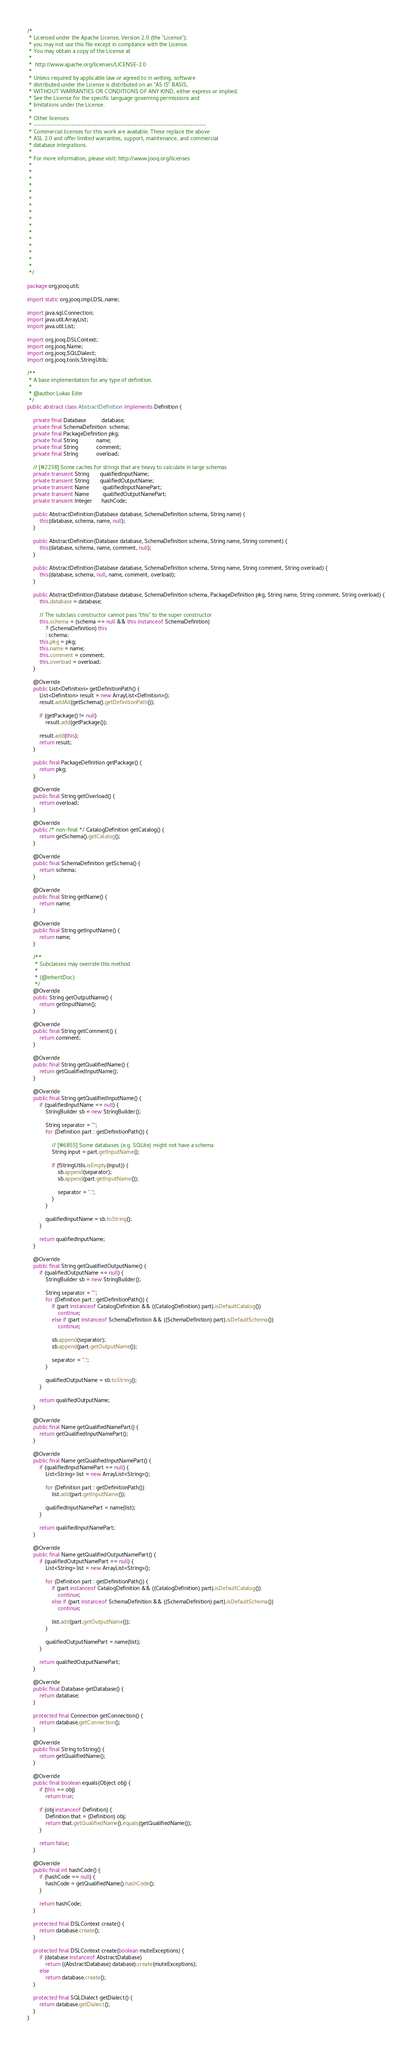Convert code to text. <code><loc_0><loc_0><loc_500><loc_500><_Java_>/*
 * Licensed under the Apache License, Version 2.0 (the "License");
 * you may not use this file except in compliance with the License.
 * You may obtain a copy of the License at
 *
 *  http://www.apache.org/licenses/LICENSE-2.0
 *
 * Unless required by applicable law or agreed to in writing, software
 * distributed under the License is distributed on an "AS IS" BASIS,
 * WITHOUT WARRANTIES OR CONDITIONS OF ANY KIND, either express or implied.
 * See the License for the specific language governing permissions and
 * limitations under the License.
 *
 * Other licenses:
 * -----------------------------------------------------------------------------
 * Commercial licenses for this work are available. These replace the above
 * ASL 2.0 and offer limited warranties, support, maintenance, and commercial
 * database integrations.
 *
 * For more information, please visit: http://www.jooq.org/licenses
 *
 *
 *
 *
 *
 *
 *
 *
 *
 *
 *
 *
 *
 *
 *
 *
 */

package org.jooq.util;

import static org.jooq.impl.DSL.name;

import java.sql.Connection;
import java.util.ArrayList;
import java.util.List;

import org.jooq.DSLContext;
import org.jooq.Name;
import org.jooq.SQLDialect;
import org.jooq.tools.StringUtils;

/**
 * A base implementation for any type of definition.
 *
 * @author Lukas Eder
 */
public abstract class AbstractDefinition implements Definition {

    private final Database          database;
    private final SchemaDefinition  schema;
    private final PackageDefinition pkg;
    private final String            name;
    private final String            comment;
    private final String            overload;

    // [#2238] Some caches for strings that are heavy to calculate in large schemas
    private transient String       qualifiedInputName;
    private transient String       qualifiedOutputName;
    private transient Name         qualifiedInputNamePart;
    private transient Name         qualifiedOutputNamePart;
    private transient Integer      hashCode;

    public AbstractDefinition(Database database, SchemaDefinition schema, String name) {
        this(database, schema, name, null);
    }

    public AbstractDefinition(Database database, SchemaDefinition schema, String name, String comment) {
        this(database, schema, name, comment, null);
    }

    public AbstractDefinition(Database database, SchemaDefinition schema, String name, String comment, String overload) {
        this(database, schema, null, name, comment, overload);
    }

    public AbstractDefinition(Database database, SchemaDefinition schema, PackageDefinition pkg, String name, String comment, String overload) {
        this.database = database;

        // The subclass constructor cannot pass "this" to the super constructor
        this.schema = (schema == null && this instanceof SchemaDefinition)
            ? (SchemaDefinition) this
            : schema;
        this.pkg = pkg;
        this.name = name;
        this.comment = comment;
        this.overload = overload;
    }

    @Override
    public List<Definition> getDefinitionPath() {
        List<Definition> result = new ArrayList<Definition>();
        result.addAll(getSchema().getDefinitionPath());

        if (getPackage() != null)
            result.add(getPackage());

        result.add(this);
        return result;
    }

    public final PackageDefinition getPackage() {
        return pkg;
    }

    @Override
    public final String getOverload() {
        return overload;
    }

    @Override
    public /* non-final */ CatalogDefinition getCatalog() {
        return getSchema().getCatalog();
    }

    @Override
    public final SchemaDefinition getSchema() {
        return schema;
    }

    @Override
    public final String getName() {
        return name;
    }

    @Override
    public final String getInputName() {
        return name;
    }

    /**
     * Subclasses may override this method
     *
     * {@inheritDoc}
     */
    @Override
    public String getOutputName() {
        return getInputName();
    }

    @Override
    public final String getComment() {
        return comment;
    }

    @Override
    public final String getQualifiedName() {
        return getQualifiedInputName();
    }

    @Override
    public final String getQualifiedInputName() {
        if (qualifiedInputName == null) {
            StringBuilder sb = new StringBuilder();

            String separator = "";
            for (Definition part : getDefinitionPath()) {

                // [#6855] Some databases (e.g. SQLite) might not have a schema
                String input = part.getInputName();

                if (!StringUtils.isEmpty(input)) {
                    sb.append(separator);
                    sb.append(part.getInputName());

                    separator = ".";
                }
            }

            qualifiedInputName = sb.toString();
        }

        return qualifiedInputName;
    }

    @Override
    public final String getQualifiedOutputName() {
        if (qualifiedOutputName == null) {
            StringBuilder sb = new StringBuilder();

            String separator = "";
            for (Definition part : getDefinitionPath()) {
                if (part instanceof CatalogDefinition && ((CatalogDefinition) part).isDefaultCatalog())
                    continue;
                else if (part instanceof SchemaDefinition && ((SchemaDefinition) part).isDefaultSchema())
                    continue;

                sb.append(separator);
                sb.append(part.getOutputName());

                separator = ".";
            }

            qualifiedOutputName = sb.toString();
        }

        return qualifiedOutputName;
    }

    @Override
    public final Name getQualifiedNamePart() {
        return getQualifiedInputNamePart();
    }

    @Override
    public final Name getQualifiedInputNamePart() {
        if (qualifiedInputNamePart == null) {
            List<String> list = new ArrayList<String>();

            for (Definition part : getDefinitionPath())
                list.add(part.getInputName());

            qualifiedInputNamePart = name(list);
        }

        return qualifiedInputNamePart;
    }

    @Override
    public final Name getQualifiedOutputNamePart() {
        if (qualifiedOutputNamePart == null) {
            List<String> list = new ArrayList<String>();

            for (Definition part : getDefinitionPath()) {
                if (part instanceof CatalogDefinition && ((CatalogDefinition) part).isDefaultCatalog())
                    continue;
                else if (part instanceof SchemaDefinition && ((SchemaDefinition) part).isDefaultSchema())
                    continue;

                list.add(part.getOutputName());
            }

            qualifiedOutputNamePart = name(list);
        }

        return qualifiedOutputNamePart;
    }

    @Override
    public final Database getDatabase() {
        return database;
    }

    protected final Connection getConnection() {
        return database.getConnection();
    }

    @Override
    public final String toString() {
        return getQualifiedName();
    }

    @Override
    public final boolean equals(Object obj) {
        if (this == obj)
            return true;

        if (obj instanceof Definition) {
            Definition that = (Definition) obj;
            return that.getQualifiedName().equals(getQualifiedName());
        }

        return false;
    }

    @Override
    public final int hashCode() {
        if (hashCode == null) {
            hashCode = getQualifiedName().hashCode();
        }

        return hashCode;
    }

    protected final DSLContext create() {
        return database.create();
    }

    protected final DSLContext create(boolean muteExceptions) {
        if (database instanceof AbstractDatabase)
            return ((AbstractDatabase) database).create(muteExceptions);
        else
            return database.create();
    }

    protected final SQLDialect getDialect() {
        return database.getDialect();
    }
}
</code> 